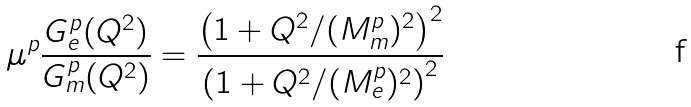<formula> <loc_0><loc_0><loc_500><loc_500>\mu ^ { p } \frac { G _ { e } ^ { p } ( Q ^ { 2 } ) } { G _ { m } ^ { p } ( Q ^ { 2 } ) } = \frac { \left ( 1 + Q ^ { 2 } / ( M _ { m } ^ { p } ) ^ { 2 } \right ) ^ { 2 } } { \left ( 1 + Q ^ { 2 } / ( M _ { e } ^ { p } ) ^ { 2 } \right ) ^ { 2 } }</formula> 